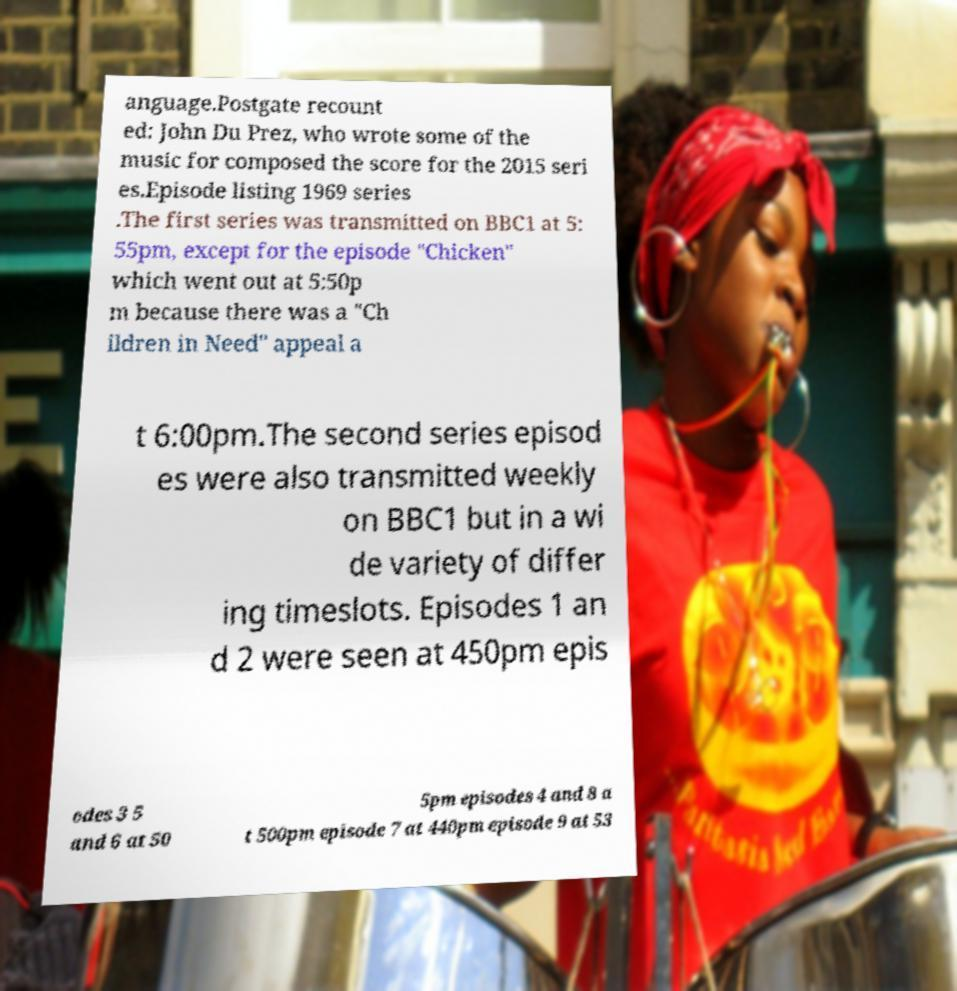There's text embedded in this image that I need extracted. Can you transcribe it verbatim? anguage.Postgate recount ed: John Du Prez, who wrote some of the music for composed the score for the 2015 seri es.Episode listing 1969 series .The first series was transmitted on BBC1 at 5: 55pm, except for the episode "Chicken" which went out at 5:50p m because there was a "Ch ildren in Need" appeal a t 6:00pm.The second series episod es were also transmitted weekly on BBC1 but in a wi de variety of differ ing timeslots. Episodes 1 an d 2 were seen at 450pm epis odes 3 5 and 6 at 50 5pm episodes 4 and 8 a t 500pm episode 7 at 440pm episode 9 at 53 